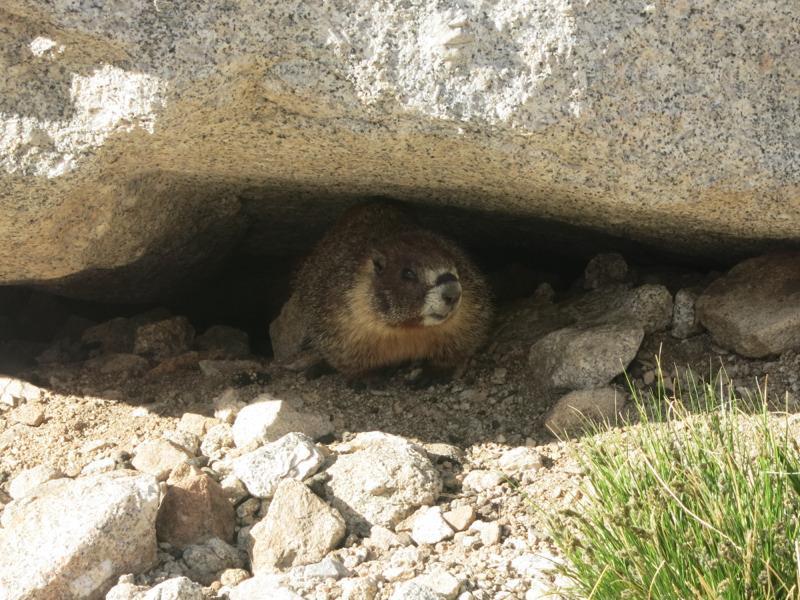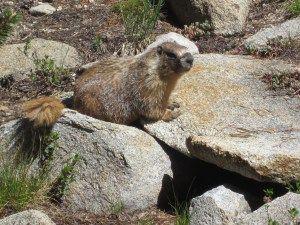The first image is the image on the left, the second image is the image on the right. Evaluate the accuracy of this statement regarding the images: "At least two animals are very close to each other.". Is it true? Answer yes or no. No. The first image is the image on the left, the second image is the image on the right. For the images displayed, is the sentence "There are at least three rodents." factually correct? Answer yes or no. No. 